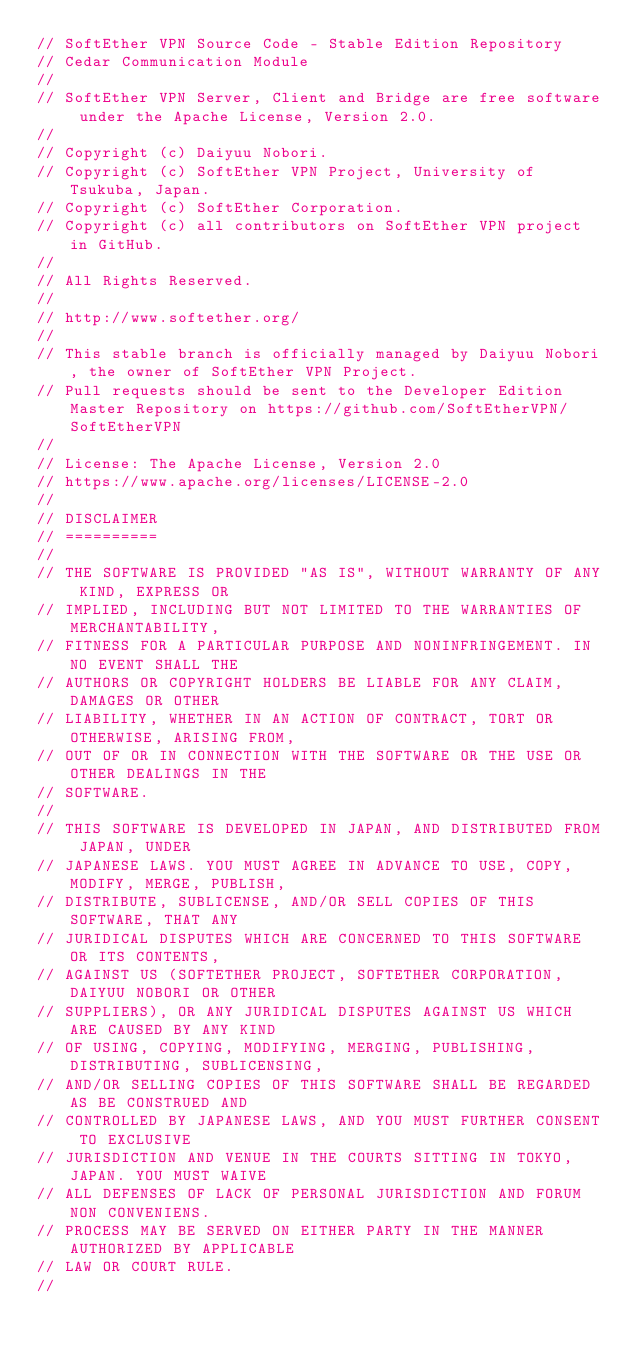Convert code to text. <code><loc_0><loc_0><loc_500><loc_500><_C_>// SoftEther VPN Source Code - Stable Edition Repository
// Cedar Communication Module
// 
// SoftEther VPN Server, Client and Bridge are free software under the Apache License, Version 2.0.
// 
// Copyright (c) Daiyuu Nobori.
// Copyright (c) SoftEther VPN Project, University of Tsukuba, Japan.
// Copyright (c) SoftEther Corporation.
// Copyright (c) all contributors on SoftEther VPN project in GitHub.
// 
// All Rights Reserved.
// 
// http://www.softether.org/
// 
// This stable branch is officially managed by Daiyuu Nobori, the owner of SoftEther VPN Project.
// Pull requests should be sent to the Developer Edition Master Repository on https://github.com/SoftEtherVPN/SoftEtherVPN
// 
// License: The Apache License, Version 2.0
// https://www.apache.org/licenses/LICENSE-2.0
// 
// DISCLAIMER
// ==========
// 
// THE SOFTWARE IS PROVIDED "AS IS", WITHOUT WARRANTY OF ANY KIND, EXPRESS OR
// IMPLIED, INCLUDING BUT NOT LIMITED TO THE WARRANTIES OF MERCHANTABILITY,
// FITNESS FOR A PARTICULAR PURPOSE AND NONINFRINGEMENT. IN NO EVENT SHALL THE
// AUTHORS OR COPYRIGHT HOLDERS BE LIABLE FOR ANY CLAIM, DAMAGES OR OTHER
// LIABILITY, WHETHER IN AN ACTION OF CONTRACT, TORT OR OTHERWISE, ARISING FROM,
// OUT OF OR IN CONNECTION WITH THE SOFTWARE OR THE USE OR OTHER DEALINGS IN THE
// SOFTWARE.
// 
// THIS SOFTWARE IS DEVELOPED IN JAPAN, AND DISTRIBUTED FROM JAPAN, UNDER
// JAPANESE LAWS. YOU MUST AGREE IN ADVANCE TO USE, COPY, MODIFY, MERGE, PUBLISH,
// DISTRIBUTE, SUBLICENSE, AND/OR SELL COPIES OF THIS SOFTWARE, THAT ANY
// JURIDICAL DISPUTES WHICH ARE CONCERNED TO THIS SOFTWARE OR ITS CONTENTS,
// AGAINST US (SOFTETHER PROJECT, SOFTETHER CORPORATION, DAIYUU NOBORI OR OTHER
// SUPPLIERS), OR ANY JURIDICAL DISPUTES AGAINST US WHICH ARE CAUSED BY ANY KIND
// OF USING, COPYING, MODIFYING, MERGING, PUBLISHING, DISTRIBUTING, SUBLICENSING,
// AND/OR SELLING COPIES OF THIS SOFTWARE SHALL BE REGARDED AS BE CONSTRUED AND
// CONTROLLED BY JAPANESE LAWS, AND YOU MUST FURTHER CONSENT TO EXCLUSIVE
// JURISDICTION AND VENUE IN THE COURTS SITTING IN TOKYO, JAPAN. YOU MUST WAIVE
// ALL DEFENSES OF LACK OF PERSONAL JURISDICTION AND FORUM NON CONVENIENS.
// PROCESS MAY BE SERVED ON EITHER PARTY IN THE MANNER AUTHORIZED BY APPLICABLE
// LAW OR COURT RULE.
// </code> 